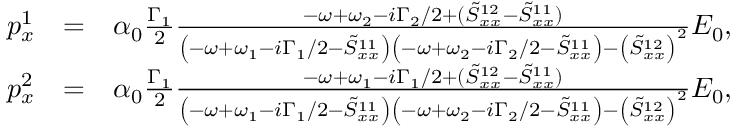<formula> <loc_0><loc_0><loc_500><loc_500>\begin{array} { r l r } { p _ { x } ^ { 1 } } & { = } & { \alpha _ { 0 } \frac { \Gamma _ { 1 } } { 2 } \frac { - \omega + \omega _ { 2 } - i \Gamma _ { 2 } / 2 + ( \tilde { S } _ { x x } ^ { 1 2 } - \tilde { S } _ { x x } ^ { 1 1 } ) } { \left ( - \omega + \omega _ { 1 } - i \Gamma _ { 1 } / 2 - \tilde { S } _ { x x } ^ { 1 1 } \right ) \left ( - \omega + \omega _ { 2 } - i \Gamma _ { 2 } / 2 - \tilde { S } _ { x x } ^ { 1 1 } \right ) - \left ( \tilde { S } _ { x x } ^ { 1 2 } \right ) ^ { 2 } } E _ { 0 } , } \\ { p _ { x } ^ { 2 } } & { = } & { \alpha _ { 0 } \frac { \Gamma _ { 1 } } { 2 } \frac { - \omega + \omega _ { 1 } - i \Gamma _ { 1 } / 2 + ( \tilde { S } _ { x x } ^ { 1 2 } - \tilde { S } _ { x x } ^ { 1 1 } ) } { \left ( - \omega + \omega _ { 1 } - i \Gamma _ { 1 } / 2 - \tilde { S } _ { x x } ^ { 1 1 } \right ) \left ( - \omega + \omega _ { 2 } - i \Gamma _ { 2 } / 2 - \tilde { S } _ { x x } ^ { 1 1 } \right ) - \left ( \tilde { S } _ { x x } ^ { 1 2 } \right ) ^ { 2 } } E _ { 0 } , } \end{array}</formula> 